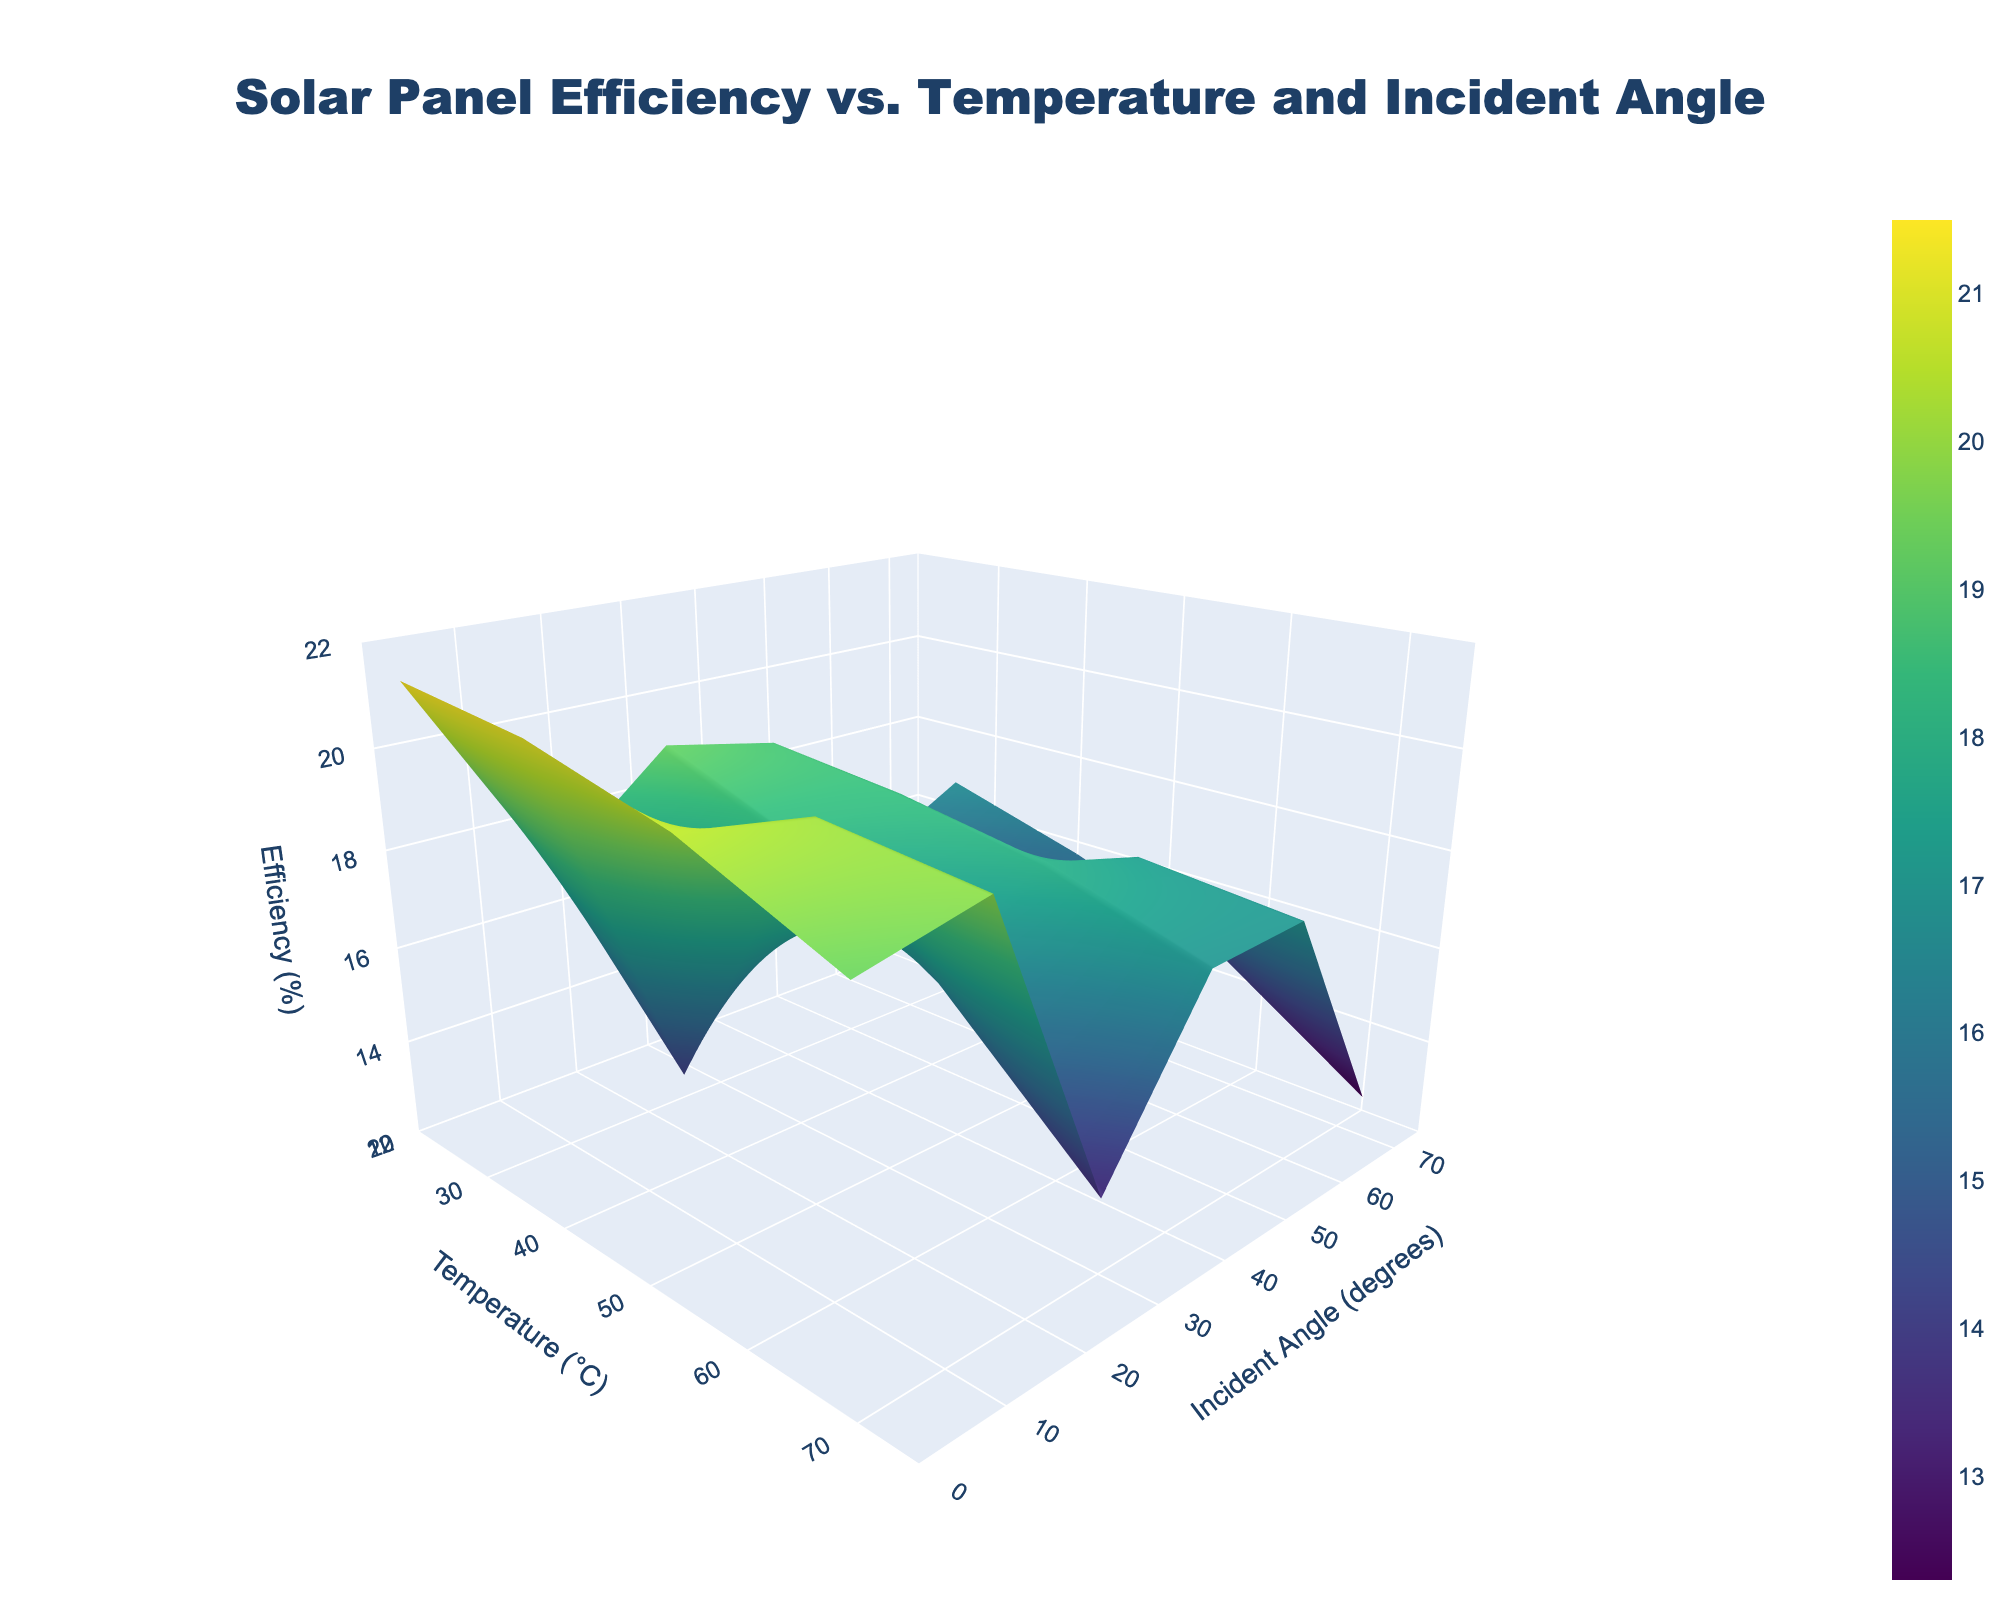What's the title of the figure? The title of the figure is typically found at the top of the plot. It provides a quick summary of what the graph is about.
Answer: Solar Panel Efficiency vs. Temperature and Incident Angle What does the z-axis represent in the plot? In this plot, the z-axis title is "Efficiency (%)". So, it represents the efficiency of the solar panel in percentage.
Answer: Efficiency (%) How does the efficiency change as the temperature increases from 25°C to 70°C at a constant incident angle of 0 degrees? By looking at the plot, identify the z-axis values along the line that corresponds to 0 degrees on the y-axis and follows the temperature changes on the x-axis. The efficiency values decrease as temperature increases.
Answer: It decreases At what incident angle and temperature is the solar panel efficiency highest? Scan through the surface plot to find the peak value on the z-axis. The highest efficiency value is 21.5%, observed at a temperature of 25°C and an incident angle of 0 degrees.
Answer: 0 degrees, 25°C What is the efficiency at 40°C and 30 degrees? Locate 40°C on the x-axis and 30 degrees on the y-axis, then read the corresponding value on the z-axis. The efficiency for these specific conditions is 19.2%.
Answer: 19.2% How does efficiency vary with temperature at a 45-degree incident angle? Look at the line that corresponds to a 45-degree incident angle and observe the changes in efficiency as the temperature increases from 25°C to 70°C. The efficiency decreases as the temperature increases.
Answer: It decreases What's the efficiency difference between 25°C and 55°C at an incident angle of 60 degrees? Find the efficiency values at 25°C and 55°C for an incident angle of 60 degrees. The values are 17.2% and 15.4%, respectively. Subtract the latter from the former. 17.2% - 15.4% = 1.8%.
Answer: 1.8% How does efficiency change with respect to incident angle at a constant temperature of 25°C? Examine the z-axis values along the line corresponding to 25°C on the x-axis and follow the changes along the y-axis. The efficiency value decreases as the incident angle increases.
Answer: It decreases Which temperature range shows the least variation in efficiency for all incident angles? Look across the surface plot to find the temperature range where the efficiency values are most consistent (less spread in z-axis values across y-axis). The temperature range of 25°C shows the least variation in efficiency for all incident angles.
Answer: 25°C Is there any incident angle at which efficiency remains constant regardless of temperature? Check if there is any vertical line (constant incident angle) where the z-values remain unchanged across different temperatures. No such incident angle is present; efficiency varies with temperature for all angles.
Answer: No 